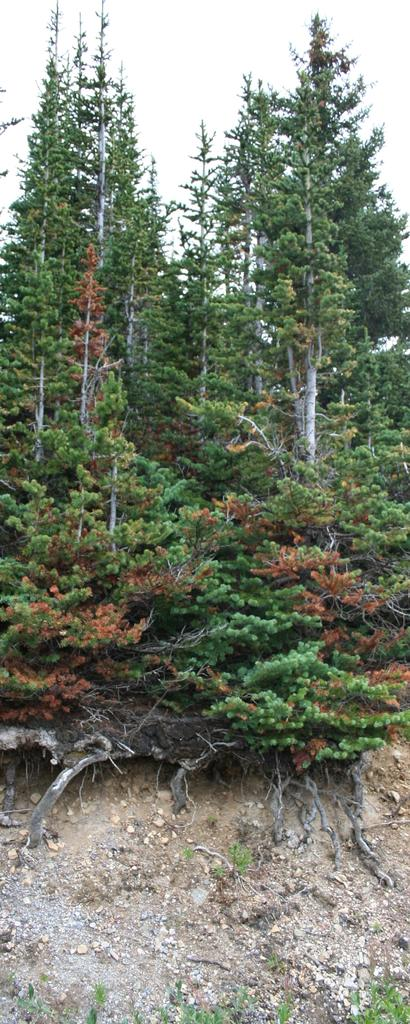What can be seen in the middle of the image? There are trees in the middle of the image. What is visible in the background of the image? There is sky visible in the background of the image. What type of mask is hanging from the tree in the image? There is no mask present in the image; it features trees and sky. What kind of paper is blowing in the wind in the image? There is no paper present in the image; it only features trees and sky. 